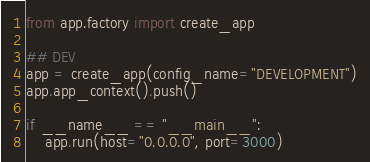<code> <loc_0><loc_0><loc_500><loc_500><_Python_>from app.factory import create_app

## DEV
app = create_app(config_name="DEVELOPMENT")
app.app_context().push()

if __name__ == "__main__":
    app.run(host="0.0.0.0", port=3000)</code> 